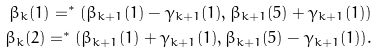Convert formula to latex. <formula><loc_0><loc_0><loc_500><loc_500>\beta _ { k } ( 1 ) = ^ { * } ( \beta _ { k + 1 } ( 1 ) - \gamma _ { k + 1 } ( 1 ) , \beta _ { k + 1 } ( 5 ) + \gamma _ { k + 1 } ( 1 ) ) \\ \beta _ { k } ( 2 ) = ^ { * } ( \beta _ { k + 1 } ( 1 ) + \gamma _ { k + 1 } ( 1 ) , \beta _ { k + 1 } ( 5 ) - \gamma _ { k + 1 } ( 1 ) ) .</formula> 